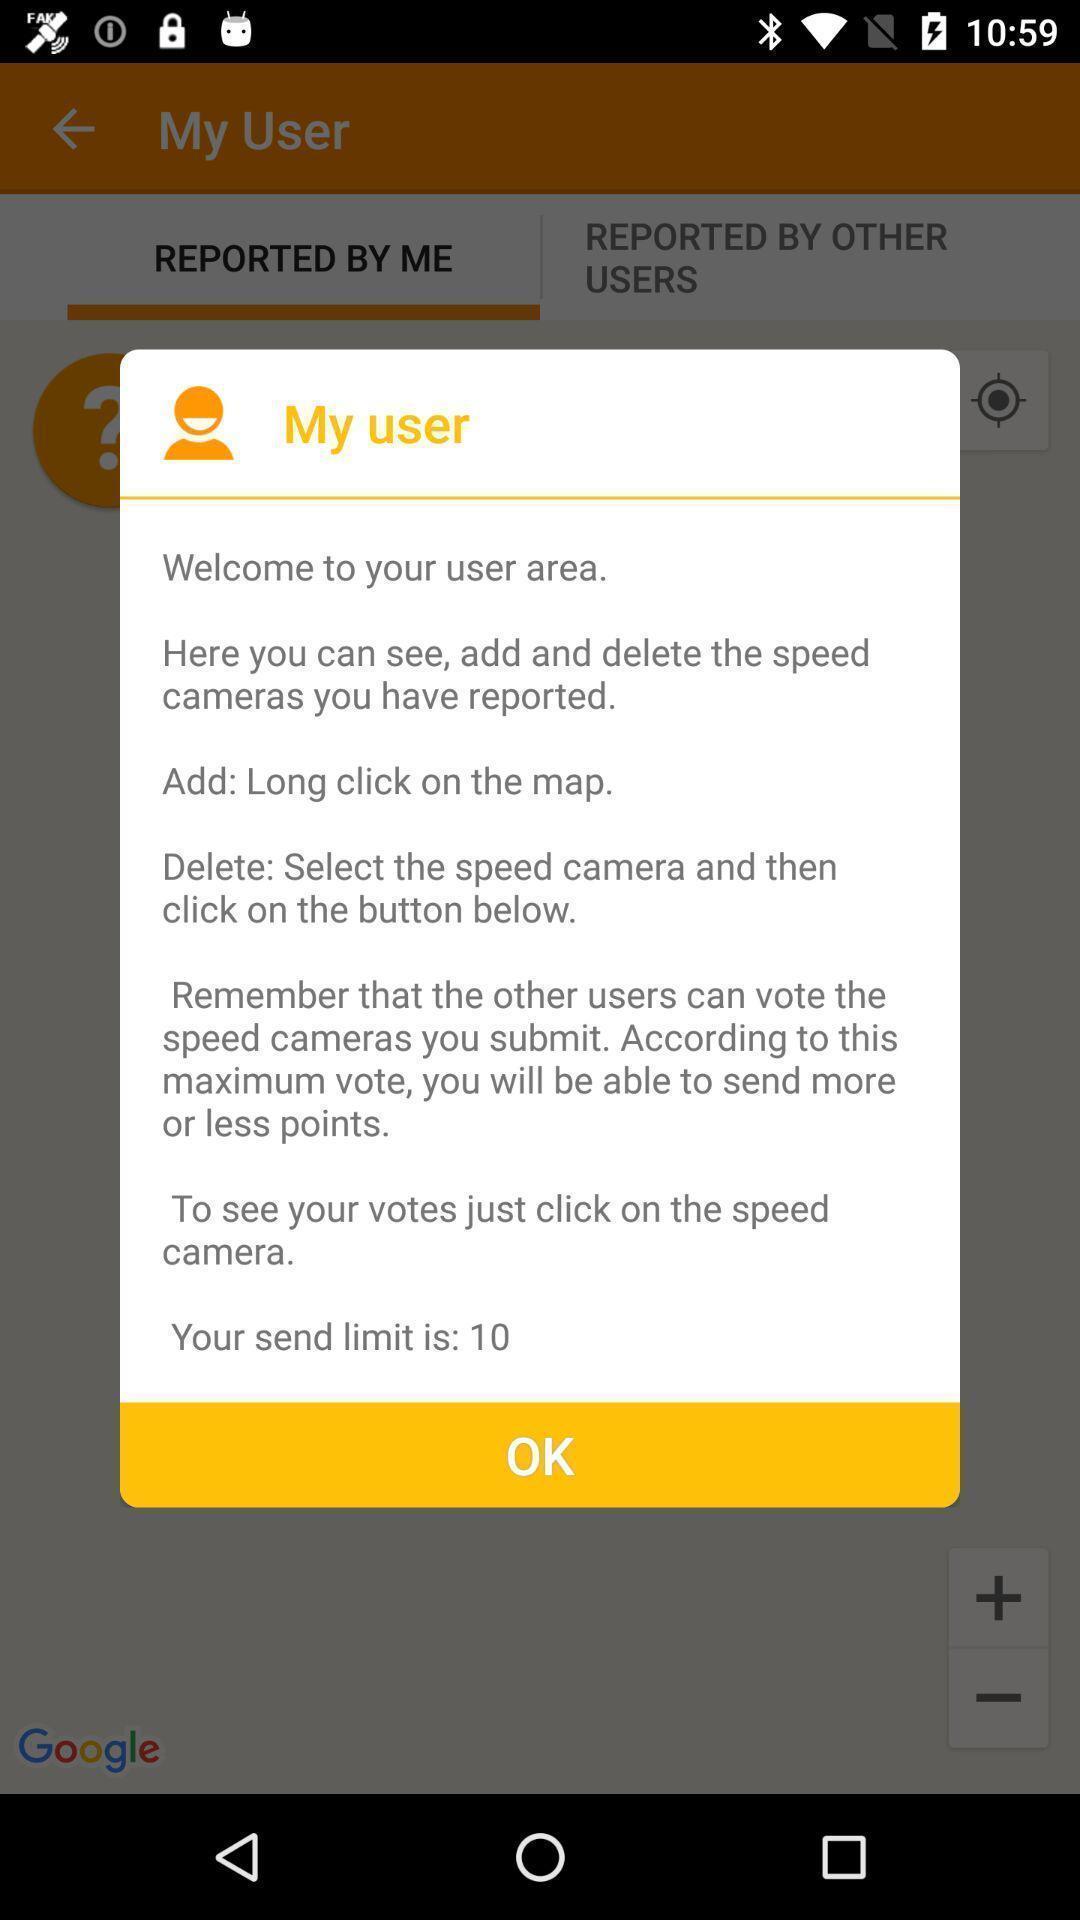Please provide a description for this image. Screen shows alert message on my user page in app. 